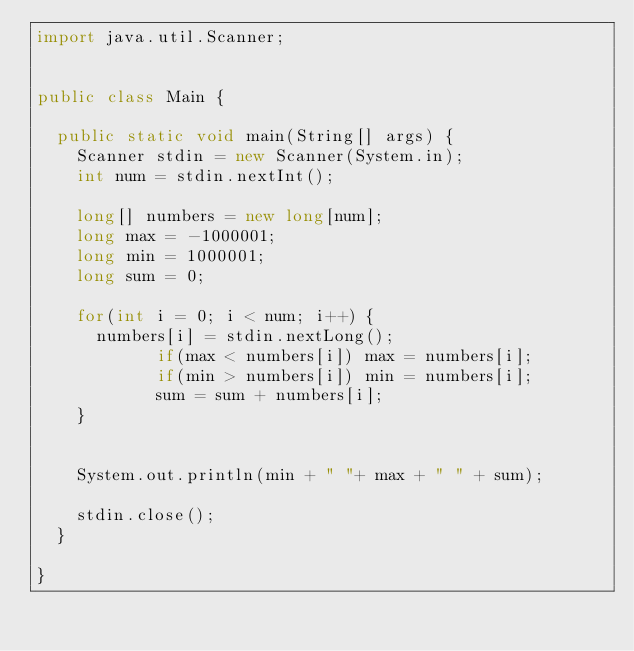Convert code to text. <code><loc_0><loc_0><loc_500><loc_500><_Java_>import java.util.Scanner;


public class Main {

	public static void main(String[] args) {
		Scanner stdin = new Scanner(System.in);
		int num = stdin.nextInt();
		
		long[] numbers = new long[num];
		long max = -1000001;
		long min = 1000001;
		long sum = 0;
	    
		for(int i = 0; i < num; i++) {
			numbers[i] = stdin.nextLong();
	          if(max < numbers[i]) max = numbers[i];
	          if(min > numbers[i]) min = numbers[i];
	          sum = sum + numbers[i];
		}
	
		
		System.out.println(min + " "+ max + " " + sum);
		
		stdin.close();
	}

}</code> 